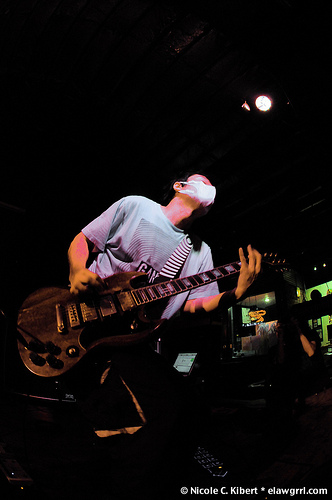<image>
Is the guitar on the man? No. The guitar is not positioned on the man. They may be near each other, but the guitar is not supported by or resting on top of the man. 